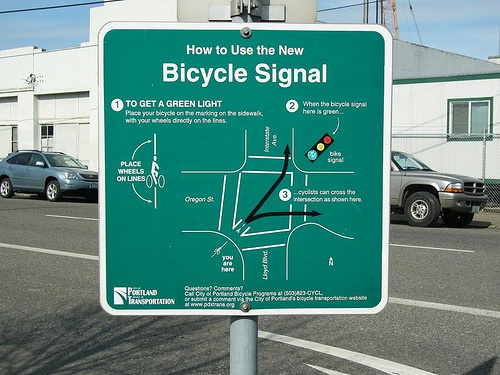Describe the objects in this image and their specific colors. I can see car in lightblue, black, gray, darkgray, and lightgray tones and car in lightblue, black, gray, and purple tones in this image. 